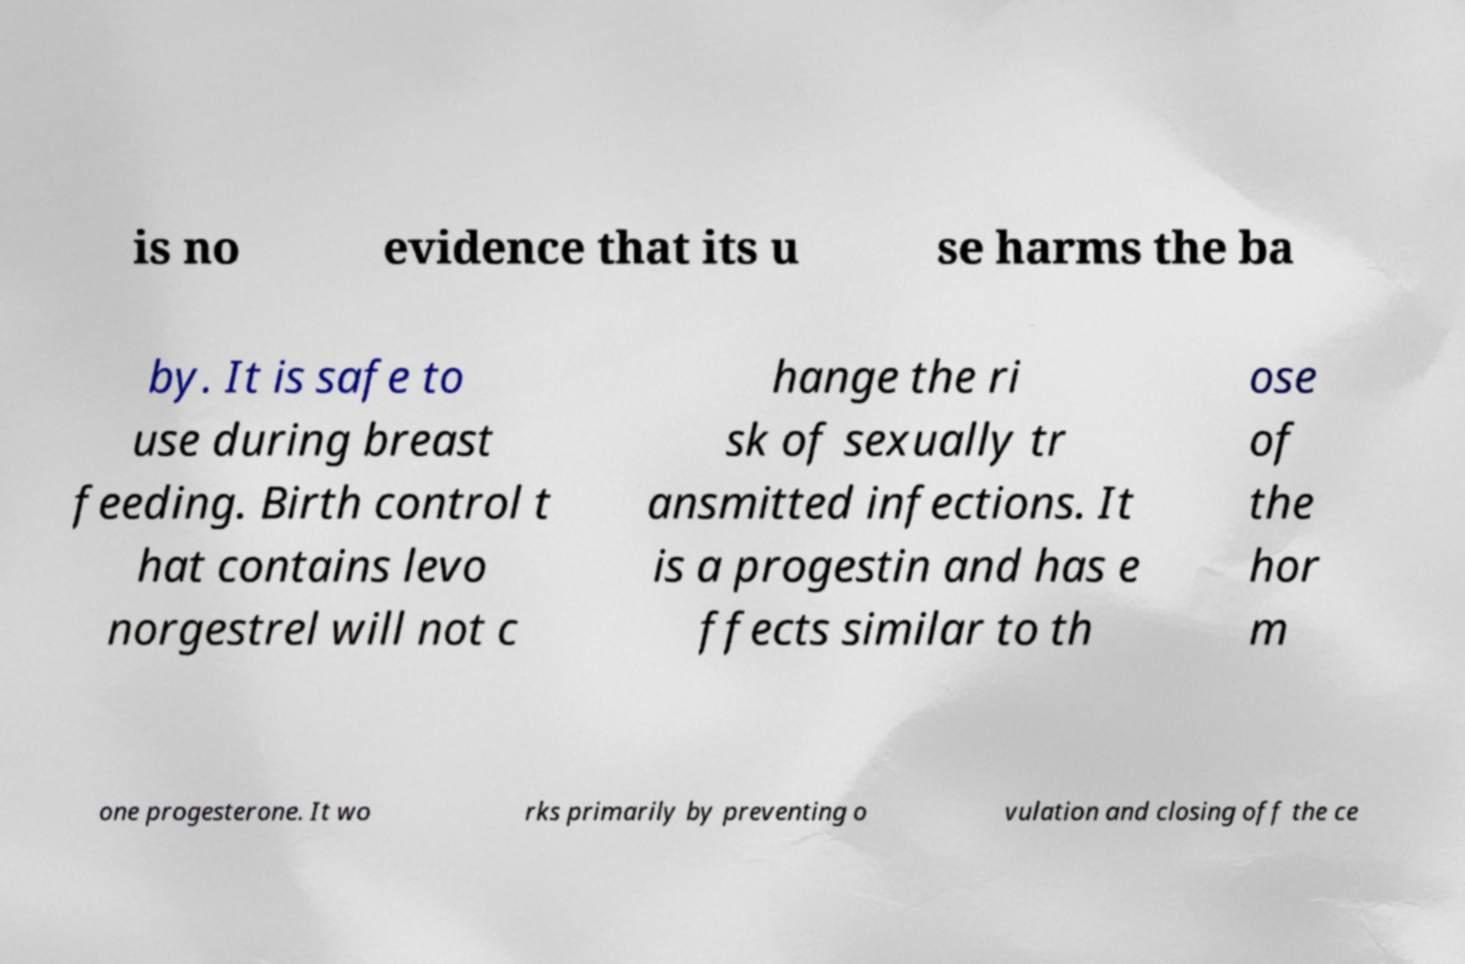There's text embedded in this image that I need extracted. Can you transcribe it verbatim? is no evidence that its u se harms the ba by. It is safe to use during breast feeding. Birth control t hat contains levo norgestrel will not c hange the ri sk of sexually tr ansmitted infections. It is a progestin and has e ffects similar to th ose of the hor m one progesterone. It wo rks primarily by preventing o vulation and closing off the ce 